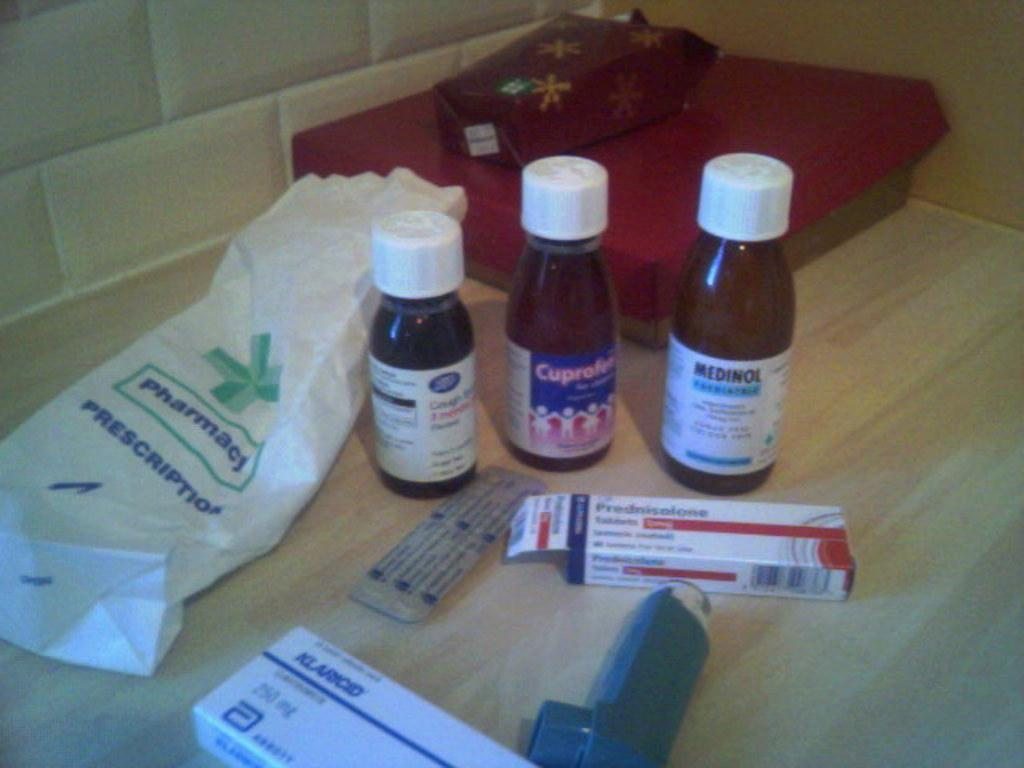<image>
Summarize the visual content of the image. The contents of a pharmacy bag are laid out on a table, including a bottle of Medinol. 